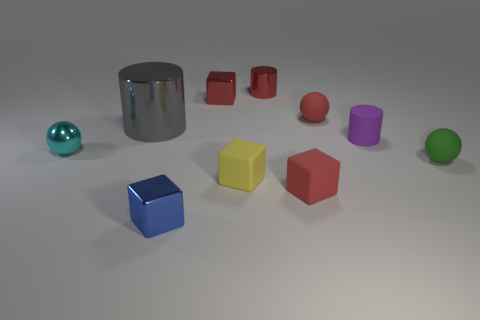Subtract all gray cubes. Subtract all gray cylinders. How many cubes are left? 4 Subtract all blocks. How many objects are left? 6 Subtract 0 purple cubes. How many objects are left? 10 Subtract all yellow objects. Subtract all green balls. How many objects are left? 8 Add 4 small matte objects. How many small matte objects are left? 9 Add 9 blue metallic things. How many blue metallic things exist? 10 